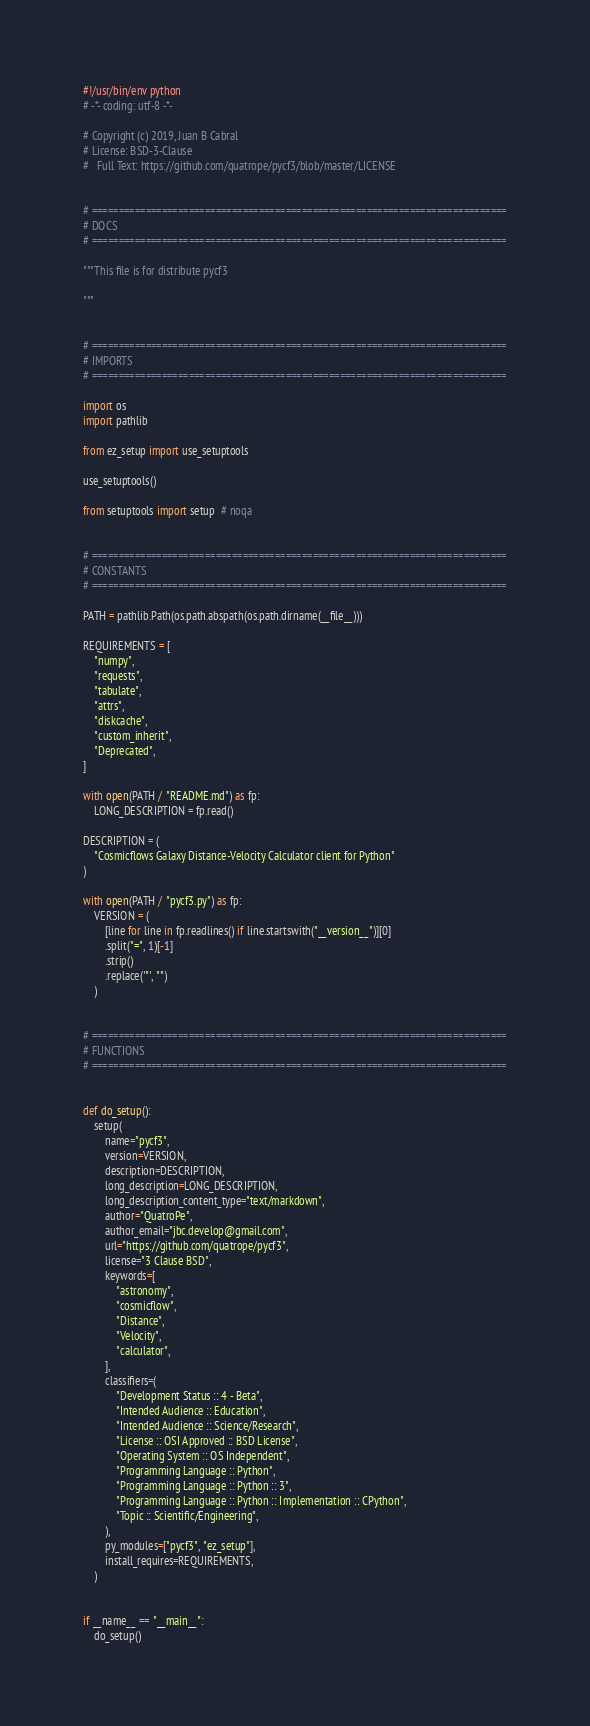Convert code to text. <code><loc_0><loc_0><loc_500><loc_500><_Python_>#!/usr/bin/env python
# -*- coding: utf-8 -*-

# Copyright (c) 2019, Juan B Cabral
# License: BSD-3-Clause
#   Full Text: https://github.com/quatrope/pycf3/blob/master/LICENSE


# =============================================================================
# DOCS
# =============================================================================

"""This file is for distribute pycf3

"""


# =============================================================================
# IMPORTS
# =============================================================================

import os
import pathlib

from ez_setup import use_setuptools

use_setuptools()

from setuptools import setup  # noqa


# =============================================================================
# CONSTANTS
# =============================================================================

PATH = pathlib.Path(os.path.abspath(os.path.dirname(__file__)))

REQUIREMENTS = [
    "numpy",
    "requests",
    "tabulate",
    "attrs",
    "diskcache",
    "custom_inherit",
    "Deprecated",
]

with open(PATH / "README.md") as fp:
    LONG_DESCRIPTION = fp.read()

DESCRIPTION = (
    "Cosmicflows Galaxy Distance-Velocity Calculator client for Python"
)

with open(PATH / "pycf3.py") as fp:
    VERSION = (
        [line for line in fp.readlines() if line.startswith("__version__")][0]
        .split("=", 1)[-1]
        .strip()
        .replace('"', "")
    )


# =============================================================================
# FUNCTIONS
# =============================================================================


def do_setup():
    setup(
        name="pycf3",
        version=VERSION,
        description=DESCRIPTION,
        long_description=LONG_DESCRIPTION,
        long_description_content_type="text/markdown",
        author="QuatroPe",
        author_email="jbc.develop@gmail.com",
        url="https://github.com/quatrope/pycf3",
        license="3 Clause BSD",
        keywords=[
            "astronomy",
            "cosmicflow",
            "Distance",
            "Velocity",
            "calculator",
        ],
        classifiers=(
            "Development Status :: 4 - Beta",
            "Intended Audience :: Education",
            "Intended Audience :: Science/Research",
            "License :: OSI Approved :: BSD License",
            "Operating System :: OS Independent",
            "Programming Language :: Python",
            "Programming Language :: Python :: 3",
            "Programming Language :: Python :: Implementation :: CPython",
            "Topic :: Scientific/Engineering",
        ),
        py_modules=["pycf3", "ez_setup"],
        install_requires=REQUIREMENTS,
    )


if __name__ == "__main__":
    do_setup()
</code> 